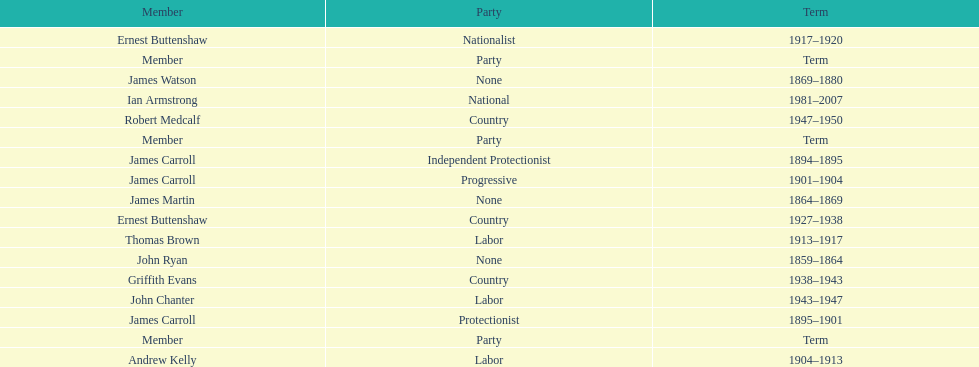How long did the fourth incarnation of the lachlan exist? 1981-2007. 